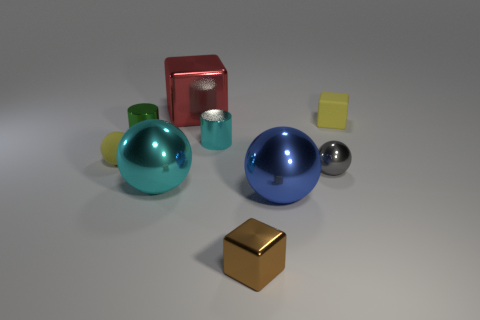Subtract all blocks. How many objects are left? 6 Subtract 0 green spheres. How many objects are left? 9 Subtract all red blocks. Subtract all red cubes. How many objects are left? 7 Add 9 small gray spheres. How many small gray spheres are left? 10 Add 6 large red objects. How many large red objects exist? 7 